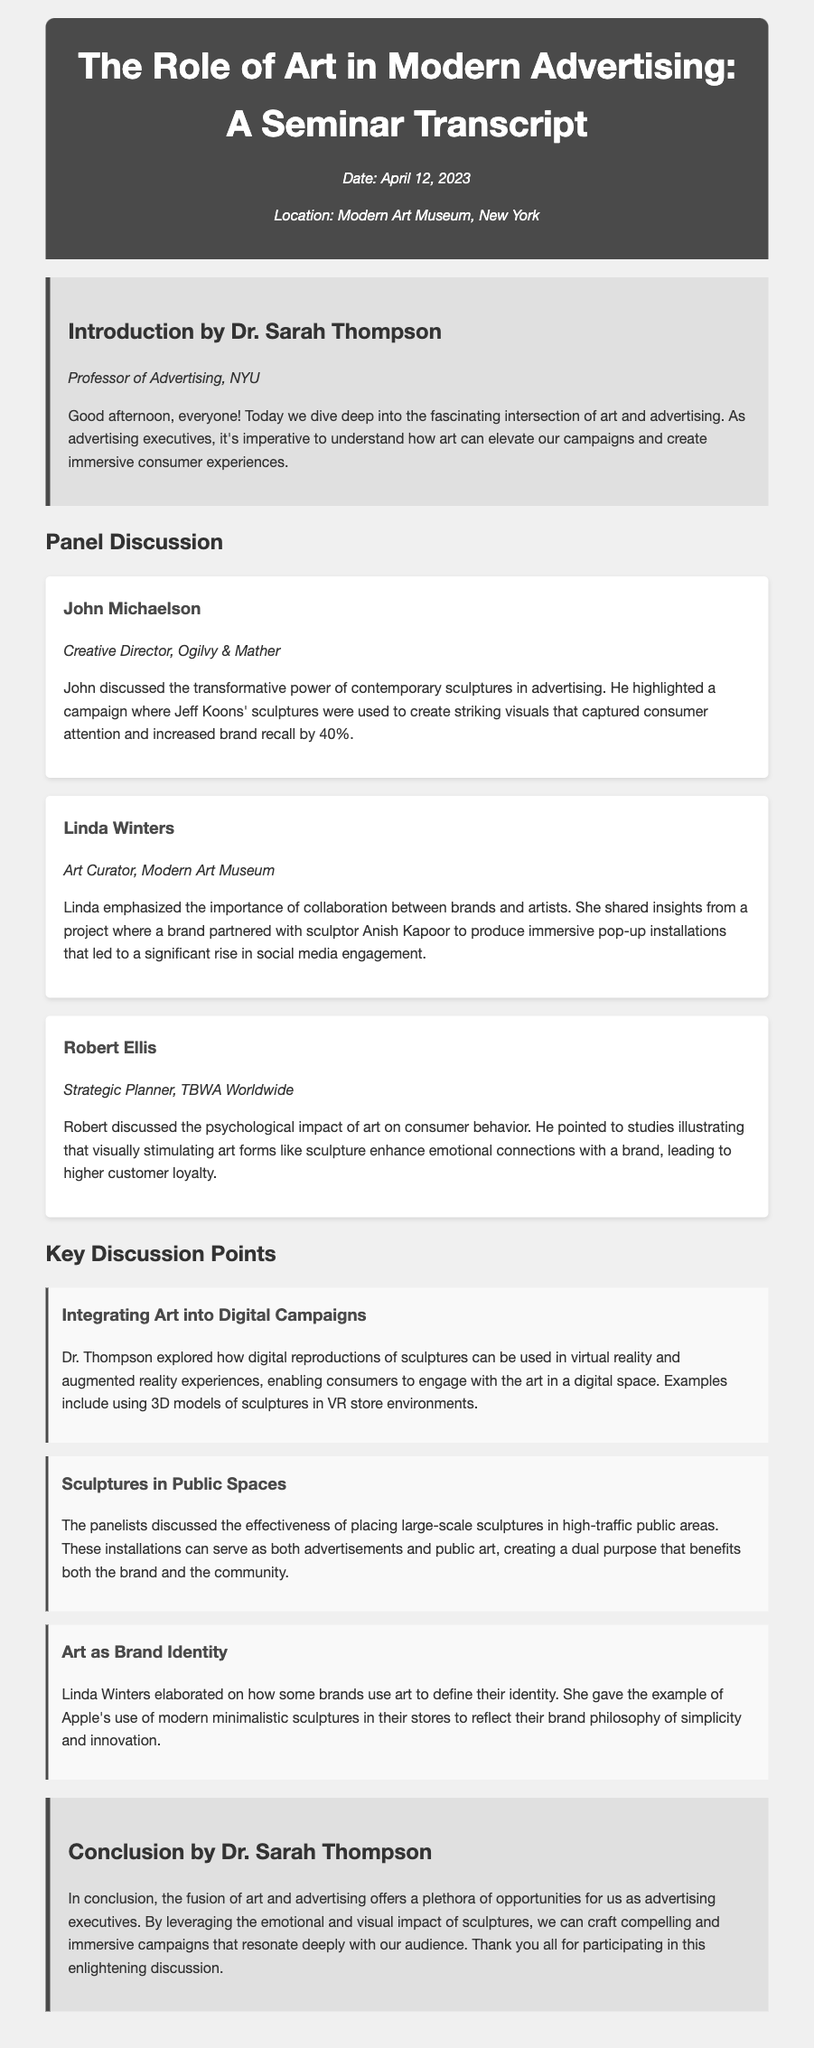What is the date of the seminar? The date of the seminar is mentioned in the document as April 12, 2023.
Answer: April 12, 2023 Who is the professor mentioned in the introduction? The introduction credits Dr. Sarah Thompson as the Professor of Advertising.
Answer: Dr. Sarah Thompson Which sculptor's sculptures were used in a discussed campaign? John Michaelson highlighted a campaign featuring sculptures by Jeff Koons to capture consumer attention.
Answer: Jeff Koons What was the increase in brand recall due to the campaign? It is noted that the campaign increased brand recall by 40%.
Answer: 40% What type of installations did Linda Winters mention in her presentation? Linda Winters discussed immersive pop-up installations created in collaboration with Anish Kapoor.
Answer: Immersive pop-up installations What does Robert Ellis say about visually stimulating art? He mentions that art forms like sculpture enhance emotional connections with a brand.
Answer: Enhance emotional connections What aspect of art does Dr. Thompson explore regarding digital campaigns? Dr. Thompson explores the use of digital reproductions of sculptures in virtual reality experiences.
Answer: Digital reproductions in VR How does art serve as part of a brand's identity according to Linda Winters? Linda Winters gave an example of Apple's use of modern minimalistic sculptures in their stores.
Answer: Modern minimalistic sculptures In which area did panelists discuss placing large-scale sculptures? The panelists discussed placing sculptures in high-traffic public areas.
Answer: High-traffic public areas 